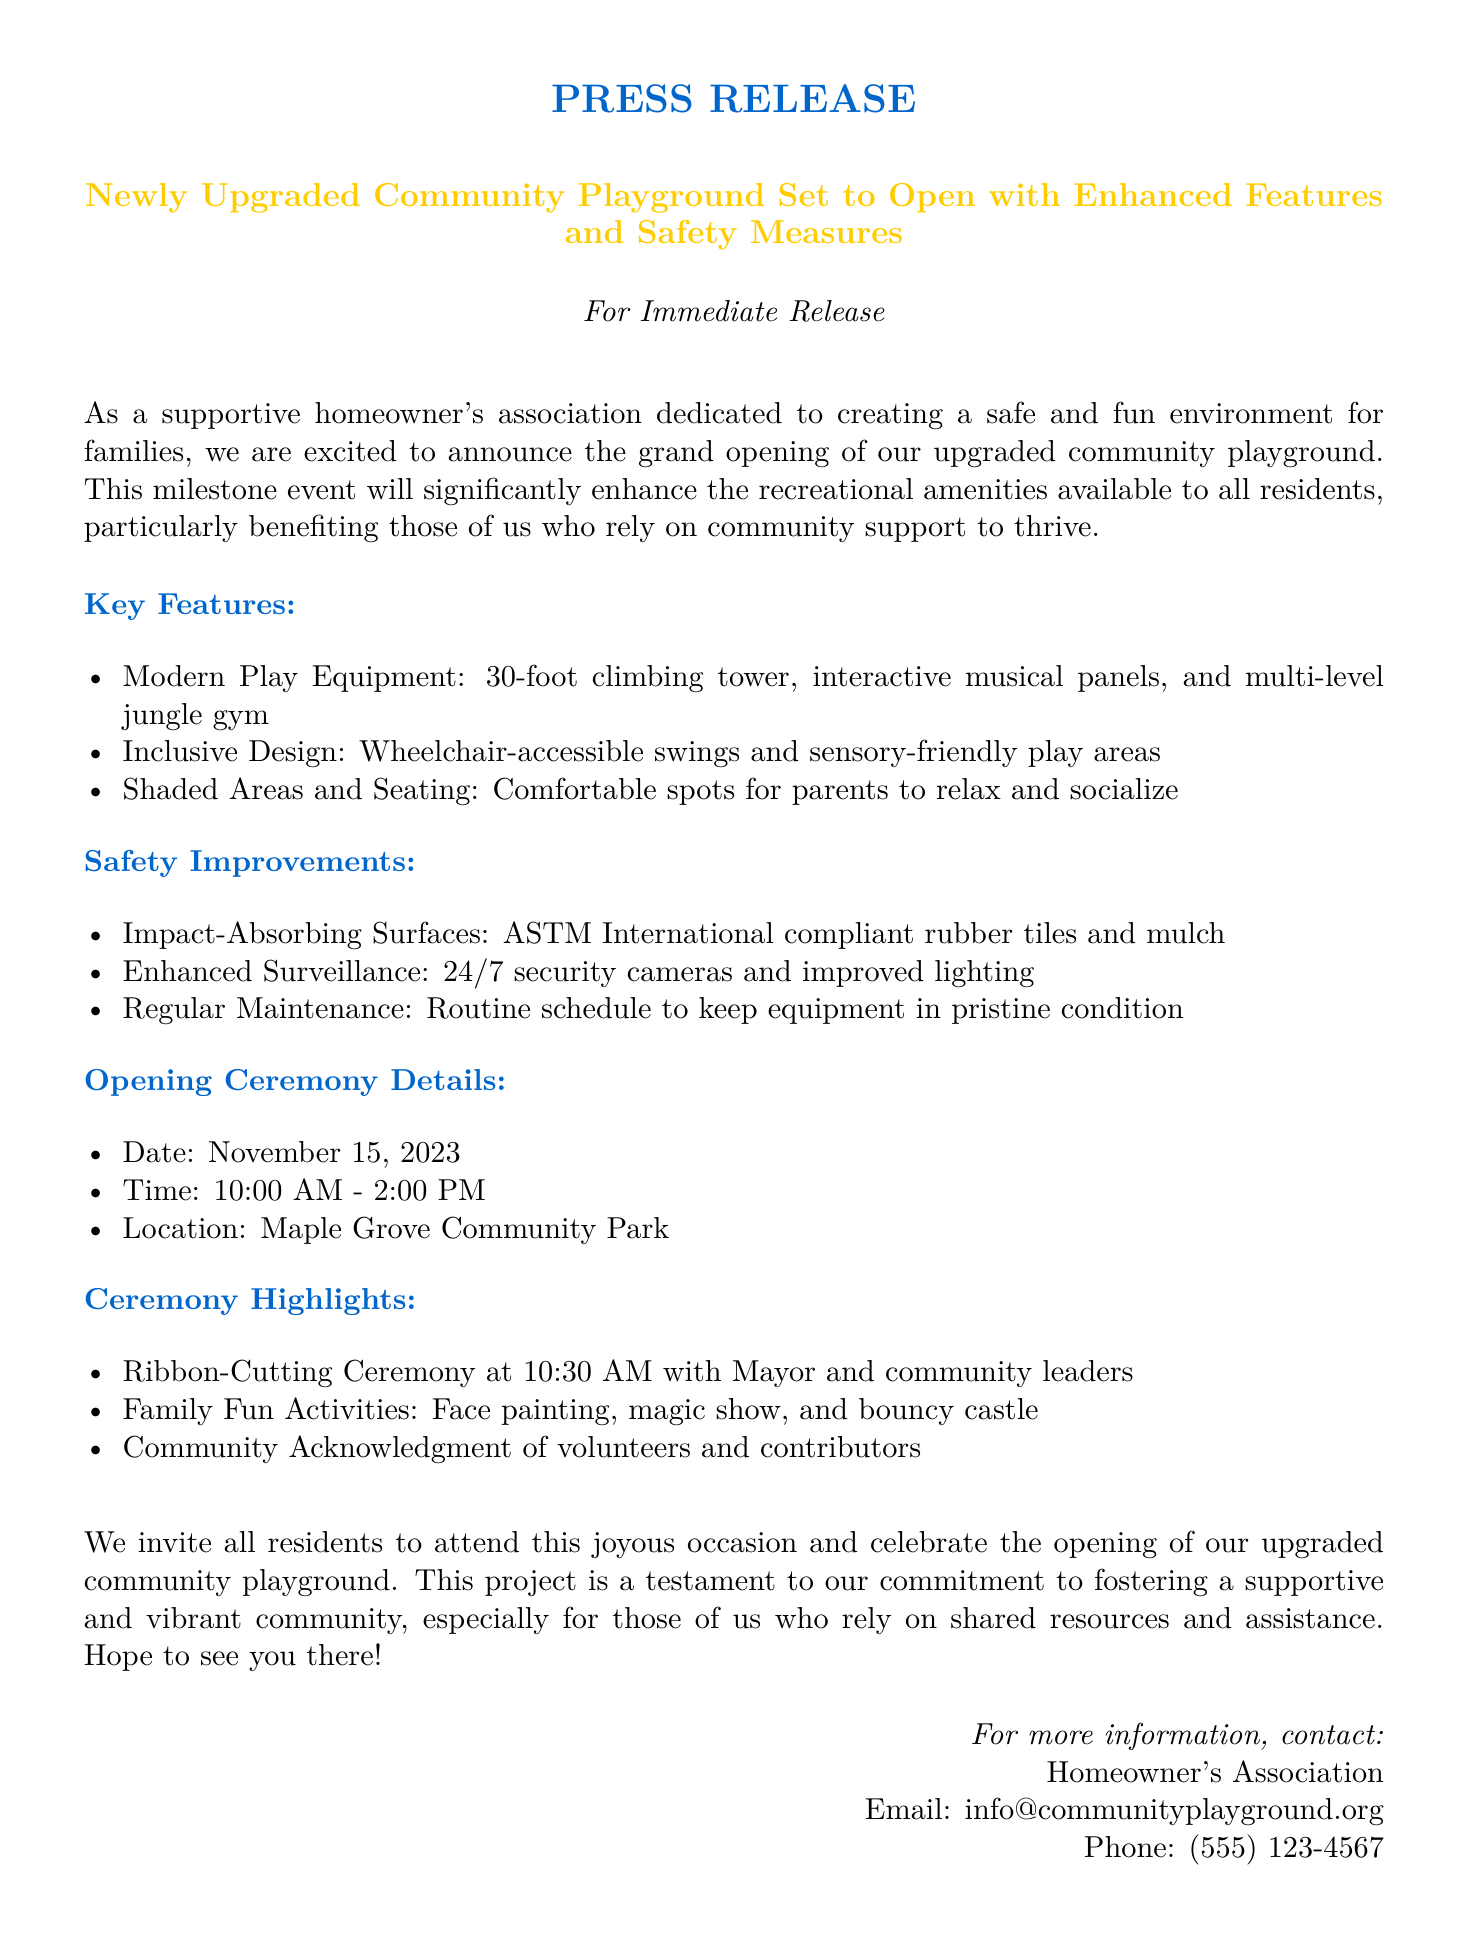what is the date of the opening ceremony? The date of the opening ceremony is explicitly stated in the document.
Answer: November 15, 2023 what specific features are included in the playground upgrade? The document lists specific features of the upgraded playground in a concise manner.
Answer: Modern Play Equipment, Inclusive Design, Shaded Areas and Seating what time does the ceremony start? The time for the ceremony is mentioned clearly in the document.
Answer: 10:00 AM who will be present for the ribbon-cutting ceremony? The document mentions key figures attending the ribbon-cutting ceremony, which requires reasoning about the event's relevance.
Answer: Mayor and community leaders what safety improvements have been made? The document outlines various safety improvements in an itemized list.
Answer: Impact-Absorbing Surfaces, Enhanced Surveillance, Regular Maintenance where is the new playground located? The location of the playground is specified in the document, indicating where residents can find it.
Answer: Maple Grove Community Park what activities are planned for the opening ceremony? The document outlines various activities and fun offerings during the ceremony, reflecting the community engagement aspect.
Answer: Face painting, magic show, and bouncy castle what organization issued this press release? The entity responsible for the press release is directly stated, identifying the source of information.
Answer: Homeowner's Association 